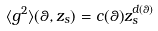Convert formula to latex. <formula><loc_0><loc_0><loc_500><loc_500>\langle g ^ { 2 } \rangle ( \theta , z _ { s } ) = c ( \theta ) z _ { s } ^ { d ( \theta ) }</formula> 